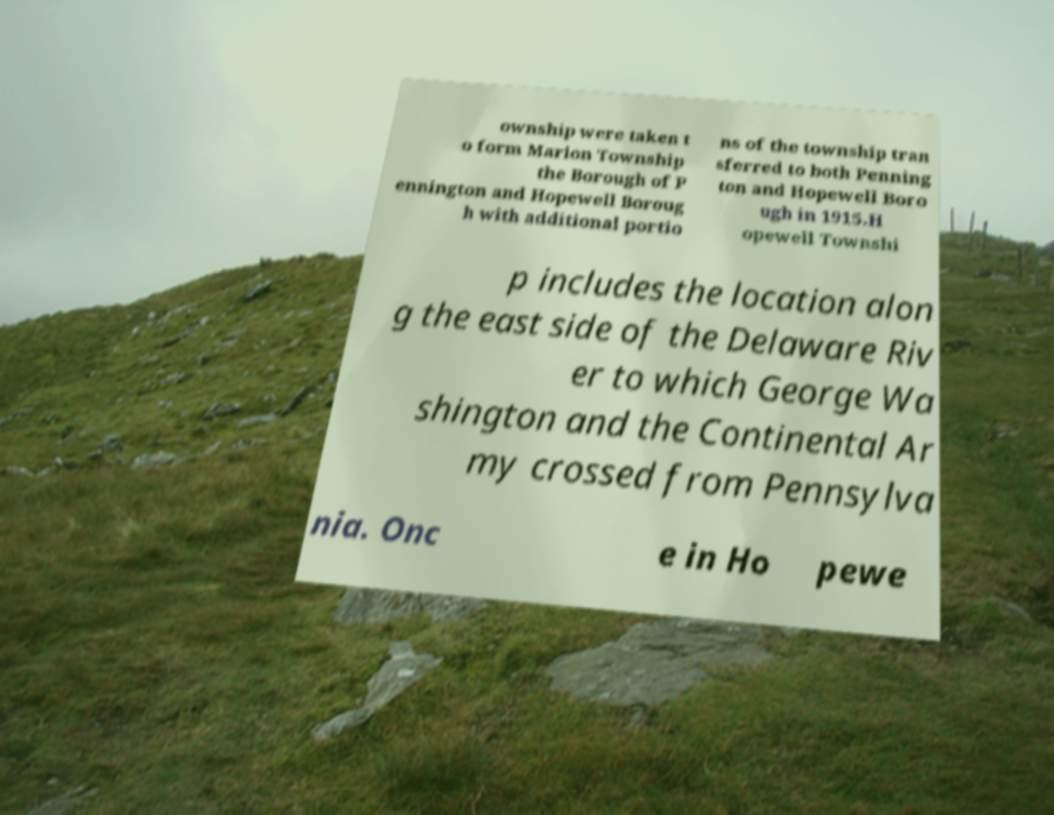For documentation purposes, I need the text within this image transcribed. Could you provide that? ownship were taken t o form Marion Township the Borough of P ennington and Hopewell Boroug h with additional portio ns of the township tran sferred to both Penning ton and Hopewell Boro ugh in 1915.H opewell Townshi p includes the location alon g the east side of the Delaware Riv er to which George Wa shington and the Continental Ar my crossed from Pennsylva nia. Onc e in Ho pewe 